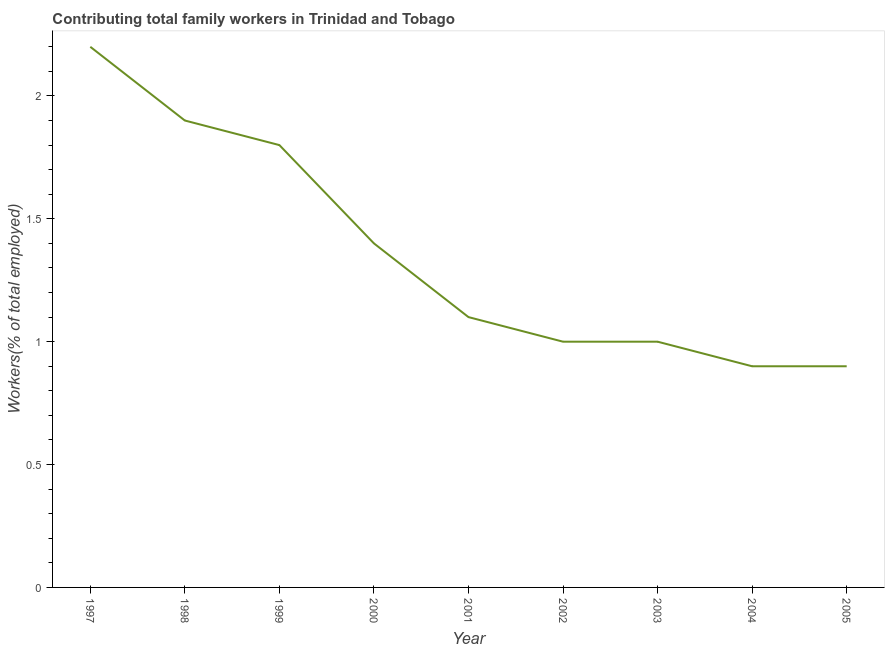What is the contributing family workers in 1998?
Provide a succinct answer. 1.9. Across all years, what is the maximum contributing family workers?
Give a very brief answer. 2.2. Across all years, what is the minimum contributing family workers?
Your answer should be very brief. 0.9. In which year was the contributing family workers maximum?
Provide a succinct answer. 1997. What is the sum of the contributing family workers?
Offer a very short reply. 12.2. What is the difference between the contributing family workers in 1997 and 2001?
Provide a short and direct response. 1.1. What is the average contributing family workers per year?
Ensure brevity in your answer.  1.36. What is the median contributing family workers?
Offer a very short reply. 1.1. What is the ratio of the contributing family workers in 1998 to that in 1999?
Offer a very short reply. 1.06. Is the contributing family workers in 1997 less than that in 1998?
Offer a very short reply. No. Is the difference between the contributing family workers in 1997 and 2000 greater than the difference between any two years?
Your response must be concise. No. What is the difference between the highest and the second highest contributing family workers?
Offer a very short reply. 0.3. Is the sum of the contributing family workers in 2001 and 2004 greater than the maximum contributing family workers across all years?
Ensure brevity in your answer.  No. What is the difference between the highest and the lowest contributing family workers?
Provide a succinct answer. 1.3. How many lines are there?
Offer a terse response. 1. Are the values on the major ticks of Y-axis written in scientific E-notation?
Make the answer very short. No. Does the graph contain grids?
Your answer should be very brief. No. What is the title of the graph?
Provide a succinct answer. Contributing total family workers in Trinidad and Tobago. What is the label or title of the Y-axis?
Your response must be concise. Workers(% of total employed). What is the Workers(% of total employed) of 1997?
Make the answer very short. 2.2. What is the Workers(% of total employed) of 1998?
Offer a terse response. 1.9. What is the Workers(% of total employed) in 1999?
Provide a succinct answer. 1.8. What is the Workers(% of total employed) of 2000?
Give a very brief answer. 1.4. What is the Workers(% of total employed) of 2001?
Your answer should be compact. 1.1. What is the Workers(% of total employed) in 2002?
Ensure brevity in your answer.  1. What is the Workers(% of total employed) in 2004?
Keep it short and to the point. 0.9. What is the Workers(% of total employed) of 2005?
Make the answer very short. 0.9. What is the difference between the Workers(% of total employed) in 1997 and 1998?
Give a very brief answer. 0.3. What is the difference between the Workers(% of total employed) in 1997 and 1999?
Your answer should be very brief. 0.4. What is the difference between the Workers(% of total employed) in 1997 and 2000?
Provide a succinct answer. 0.8. What is the difference between the Workers(% of total employed) in 1997 and 2001?
Ensure brevity in your answer.  1.1. What is the difference between the Workers(% of total employed) in 1997 and 2002?
Provide a succinct answer. 1.2. What is the difference between the Workers(% of total employed) in 1997 and 2003?
Your answer should be very brief. 1.2. What is the difference between the Workers(% of total employed) in 1997 and 2004?
Your response must be concise. 1.3. What is the difference between the Workers(% of total employed) in 1997 and 2005?
Your answer should be compact. 1.3. What is the difference between the Workers(% of total employed) in 1998 and 1999?
Make the answer very short. 0.1. What is the difference between the Workers(% of total employed) in 1998 and 2001?
Keep it short and to the point. 0.8. What is the difference between the Workers(% of total employed) in 1998 and 2004?
Your response must be concise. 1. What is the difference between the Workers(% of total employed) in 1998 and 2005?
Provide a succinct answer. 1. What is the difference between the Workers(% of total employed) in 1999 and 2002?
Provide a succinct answer. 0.8. What is the difference between the Workers(% of total employed) in 1999 and 2005?
Make the answer very short. 0.9. What is the difference between the Workers(% of total employed) in 2000 and 2002?
Give a very brief answer. 0.4. What is the difference between the Workers(% of total employed) in 2000 and 2004?
Your response must be concise. 0.5. What is the difference between the Workers(% of total employed) in 2000 and 2005?
Your answer should be compact. 0.5. What is the difference between the Workers(% of total employed) in 2001 and 2002?
Offer a very short reply. 0.1. What is the difference between the Workers(% of total employed) in 2001 and 2004?
Keep it short and to the point. 0.2. What is the difference between the Workers(% of total employed) in 2001 and 2005?
Ensure brevity in your answer.  0.2. What is the difference between the Workers(% of total employed) in 2002 and 2003?
Provide a short and direct response. 0. What is the difference between the Workers(% of total employed) in 2002 and 2005?
Provide a succinct answer. 0.1. What is the ratio of the Workers(% of total employed) in 1997 to that in 1998?
Offer a terse response. 1.16. What is the ratio of the Workers(% of total employed) in 1997 to that in 1999?
Your answer should be compact. 1.22. What is the ratio of the Workers(% of total employed) in 1997 to that in 2000?
Make the answer very short. 1.57. What is the ratio of the Workers(% of total employed) in 1997 to that in 2001?
Give a very brief answer. 2. What is the ratio of the Workers(% of total employed) in 1997 to that in 2002?
Offer a terse response. 2.2. What is the ratio of the Workers(% of total employed) in 1997 to that in 2004?
Offer a terse response. 2.44. What is the ratio of the Workers(% of total employed) in 1997 to that in 2005?
Your answer should be compact. 2.44. What is the ratio of the Workers(% of total employed) in 1998 to that in 1999?
Provide a succinct answer. 1.06. What is the ratio of the Workers(% of total employed) in 1998 to that in 2000?
Your answer should be compact. 1.36. What is the ratio of the Workers(% of total employed) in 1998 to that in 2001?
Offer a terse response. 1.73. What is the ratio of the Workers(% of total employed) in 1998 to that in 2002?
Offer a terse response. 1.9. What is the ratio of the Workers(% of total employed) in 1998 to that in 2003?
Provide a succinct answer. 1.9. What is the ratio of the Workers(% of total employed) in 1998 to that in 2004?
Make the answer very short. 2.11. What is the ratio of the Workers(% of total employed) in 1998 to that in 2005?
Your answer should be compact. 2.11. What is the ratio of the Workers(% of total employed) in 1999 to that in 2000?
Give a very brief answer. 1.29. What is the ratio of the Workers(% of total employed) in 1999 to that in 2001?
Ensure brevity in your answer.  1.64. What is the ratio of the Workers(% of total employed) in 1999 to that in 2004?
Offer a terse response. 2. What is the ratio of the Workers(% of total employed) in 1999 to that in 2005?
Provide a short and direct response. 2. What is the ratio of the Workers(% of total employed) in 2000 to that in 2001?
Provide a short and direct response. 1.27. What is the ratio of the Workers(% of total employed) in 2000 to that in 2003?
Your answer should be very brief. 1.4. What is the ratio of the Workers(% of total employed) in 2000 to that in 2004?
Your answer should be very brief. 1.56. What is the ratio of the Workers(% of total employed) in 2000 to that in 2005?
Provide a succinct answer. 1.56. What is the ratio of the Workers(% of total employed) in 2001 to that in 2003?
Ensure brevity in your answer.  1.1. What is the ratio of the Workers(% of total employed) in 2001 to that in 2004?
Keep it short and to the point. 1.22. What is the ratio of the Workers(% of total employed) in 2001 to that in 2005?
Your response must be concise. 1.22. What is the ratio of the Workers(% of total employed) in 2002 to that in 2003?
Offer a terse response. 1. What is the ratio of the Workers(% of total employed) in 2002 to that in 2004?
Provide a short and direct response. 1.11. What is the ratio of the Workers(% of total employed) in 2002 to that in 2005?
Make the answer very short. 1.11. What is the ratio of the Workers(% of total employed) in 2003 to that in 2004?
Provide a short and direct response. 1.11. What is the ratio of the Workers(% of total employed) in 2003 to that in 2005?
Ensure brevity in your answer.  1.11. 